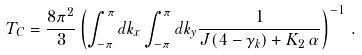<formula> <loc_0><loc_0><loc_500><loc_500>T _ { C } = \frac { 8 \pi ^ { 2 } } { 3 } \left ( \int _ { - \pi } ^ { \pi } d k _ { x } \int _ { - \pi } ^ { \pi } d k _ { y } \frac { 1 } { J ( 4 - \gamma _ { k } ) + K _ { 2 } \, \alpha } \right ) ^ { - 1 } \, .</formula> 